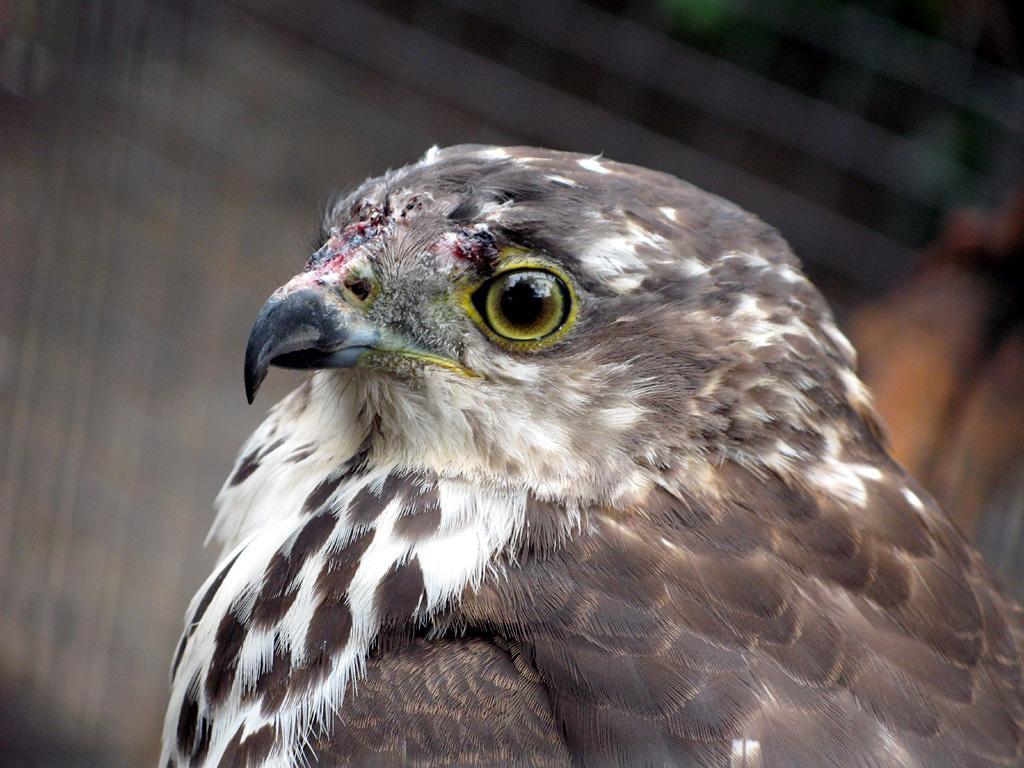Can you describe this image briefly? In this picture there is a bird in the center of the image. 